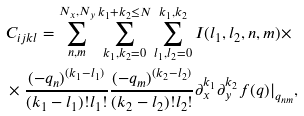<formula> <loc_0><loc_0><loc_500><loc_500>& C _ { i j k l } = \sum _ { n , m } ^ { N _ { x } , N _ { y } } \sum _ { k _ { 1 } , k _ { 2 } = 0 } ^ { k _ { 1 } + k _ { 2 } \leq N } \sum _ { l _ { 1 } , l _ { 2 } = 0 } ^ { k _ { 1 } , k _ { 2 } } I ( l _ { 1 } , l _ { 2 } , n , m ) \times \\ & \times \frac { ( - q _ { n } ) ^ { ( k _ { 1 } - l _ { 1 } ) } } { ( k _ { 1 } - l _ { 1 } ) ! l _ { 1 } ! } \frac { ( - q _ { m } ) ^ { ( k _ { 2 } - l _ { 2 } ) } } { ( k _ { 2 } - l _ { 2 } ) ! l _ { 2 } ! } \partial _ { x } ^ { k _ { 1 } } \partial _ { y } ^ { k _ { 2 } } f ( { q } ) | _ { q _ { n m } } ,</formula> 